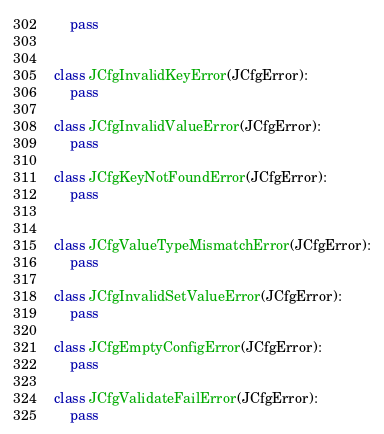Convert code to text. <code><loc_0><loc_0><loc_500><loc_500><_Python_>    pass


class JCfgInvalidKeyError(JCfgError):
    pass

class JCfgInvalidValueError(JCfgError):
    pass

class JCfgKeyNotFoundError(JCfgError):
    pass


class JCfgValueTypeMismatchError(JCfgError):
    pass

class JCfgInvalidSetValueError(JCfgError):
    pass

class JCfgEmptyConfigError(JCfgError):
    pass

class JCfgValidateFailError(JCfgError):
    pass
</code> 